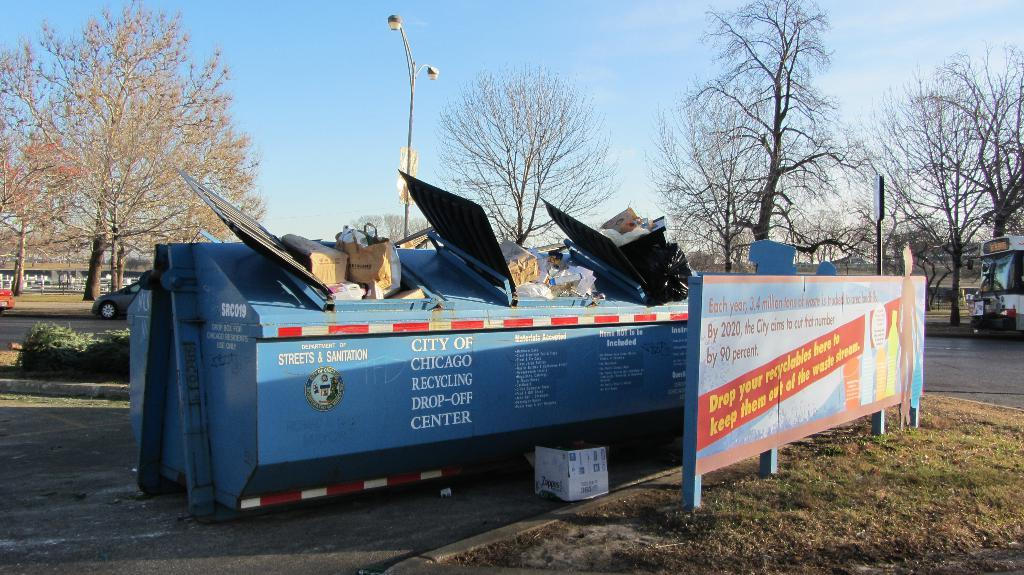<image>
Provide a brief description of the given image. Blue garbage can which is located in Chicago. 